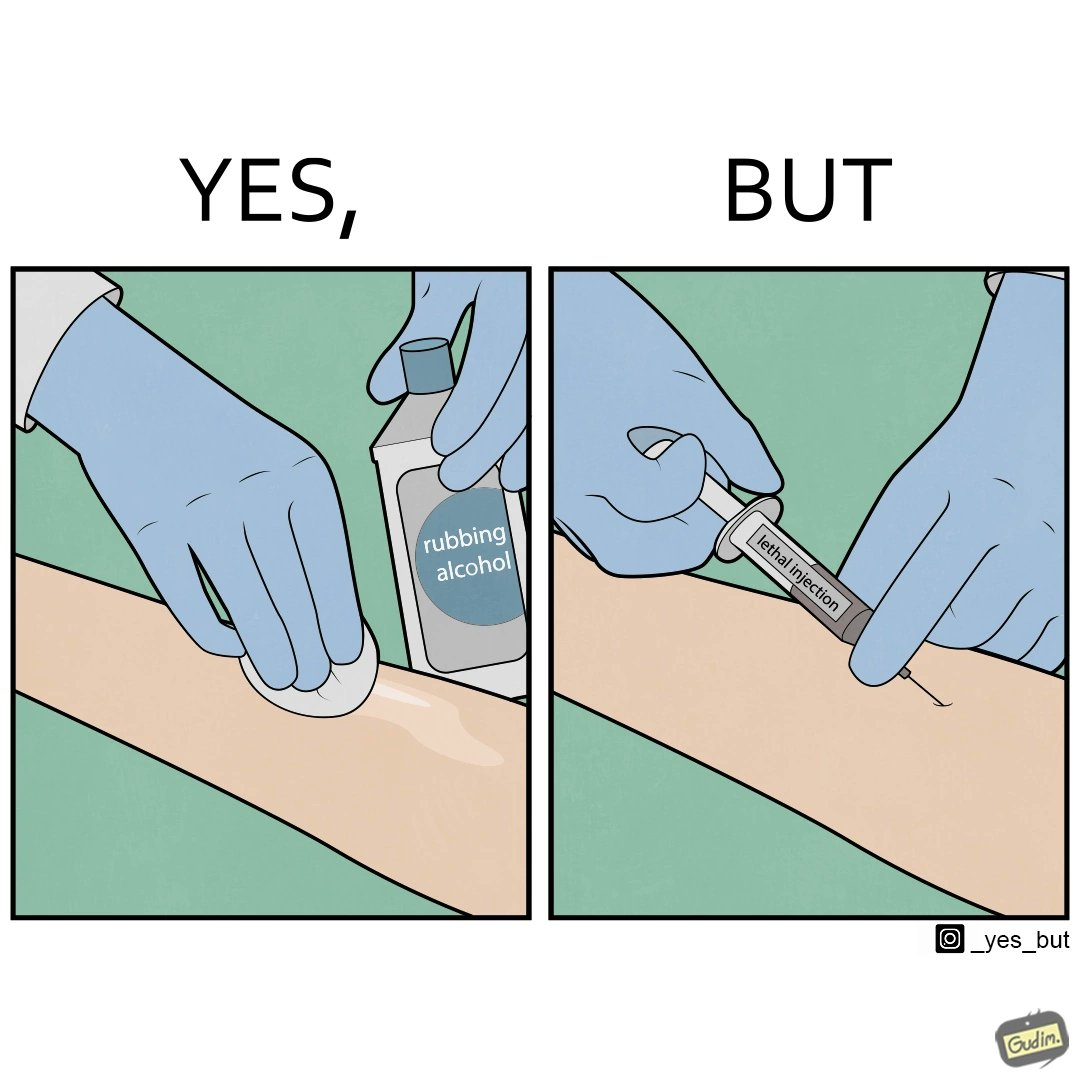Describe what you see in the left and right parts of this image. In the left part of the image: a doctor/nurse rubbing alcohol on a patient's arm. In the right part of the image: a doctor/nurse injecting a 'lethal injection' into the patient's arm. 